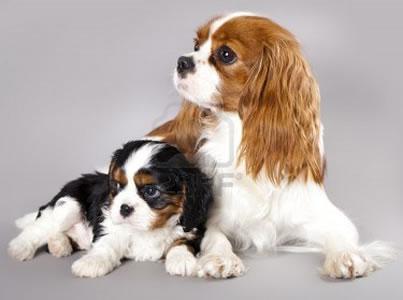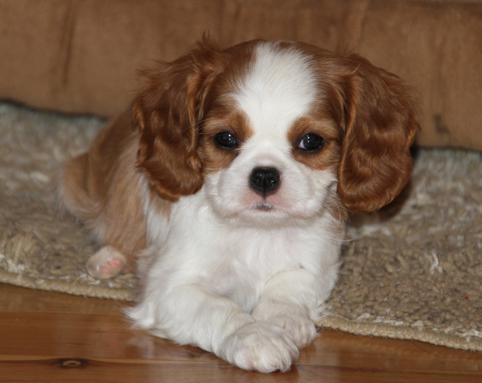The first image is the image on the left, the second image is the image on the right. Given the left and right images, does the statement "There are three mammals visible" hold true? Answer yes or no. Yes. The first image is the image on the left, the second image is the image on the right. Examine the images to the left and right. Is the description "Two animals, including at least one spaniel dog, pose side-by-side in one image." accurate? Answer yes or no. Yes. 